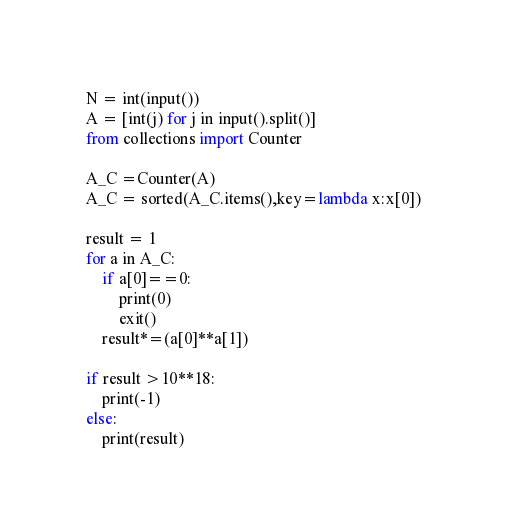<code> <loc_0><loc_0><loc_500><loc_500><_Python_>N = int(input())
A = [int(j) for j in input().split()]
from collections import Counter

A_C =Counter(A)
A_C = sorted(A_C.items(),key=lambda x:x[0])

result = 1
for a in A_C:
    if a[0]==0:
        print(0)
        exit()
    result*=(a[0]**a[1])

if result >10**18:
    print(-1)
else:
    print(result)</code> 